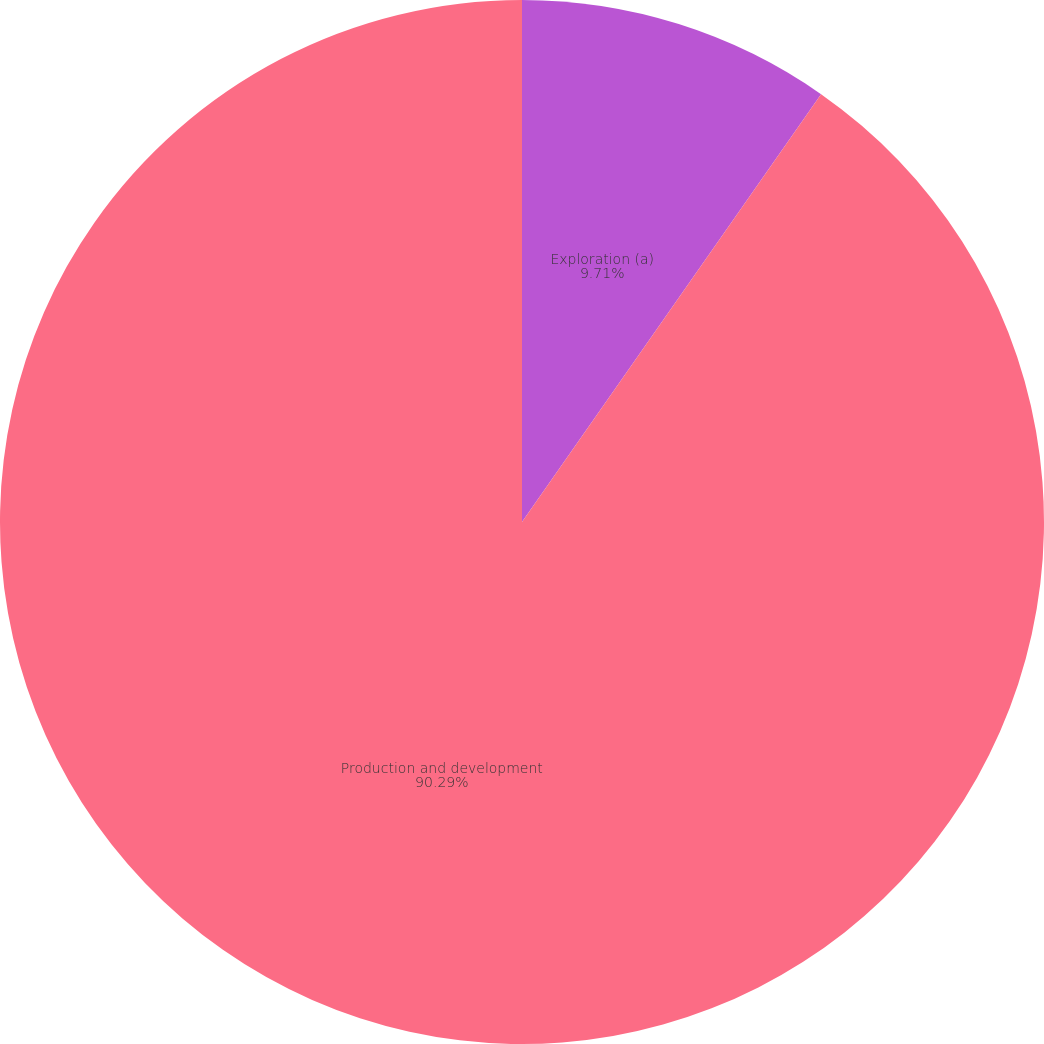Convert chart to OTSL. <chart><loc_0><loc_0><loc_500><loc_500><pie_chart><fcel>Exploration (a)<fcel>Production and development<nl><fcel>9.71%<fcel>90.29%<nl></chart> 